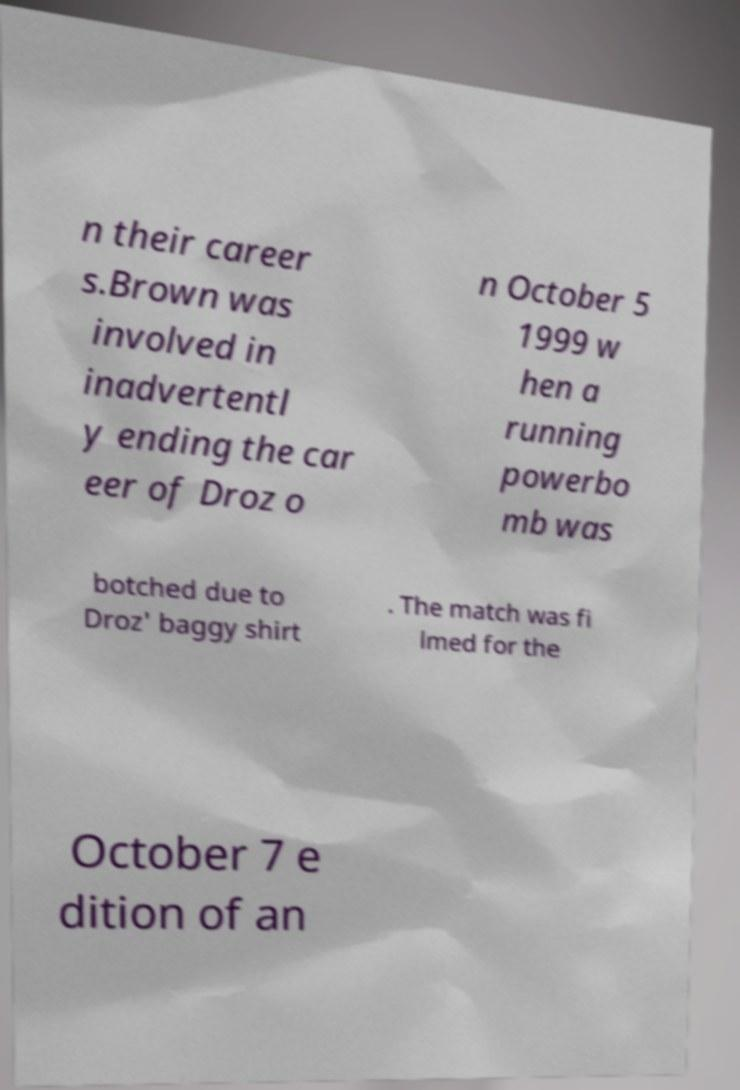Can you accurately transcribe the text from the provided image for me? n their career s.Brown was involved in inadvertentl y ending the car eer of Droz o n October 5 1999 w hen a running powerbo mb was botched due to Droz' baggy shirt . The match was fi lmed for the October 7 e dition of an 